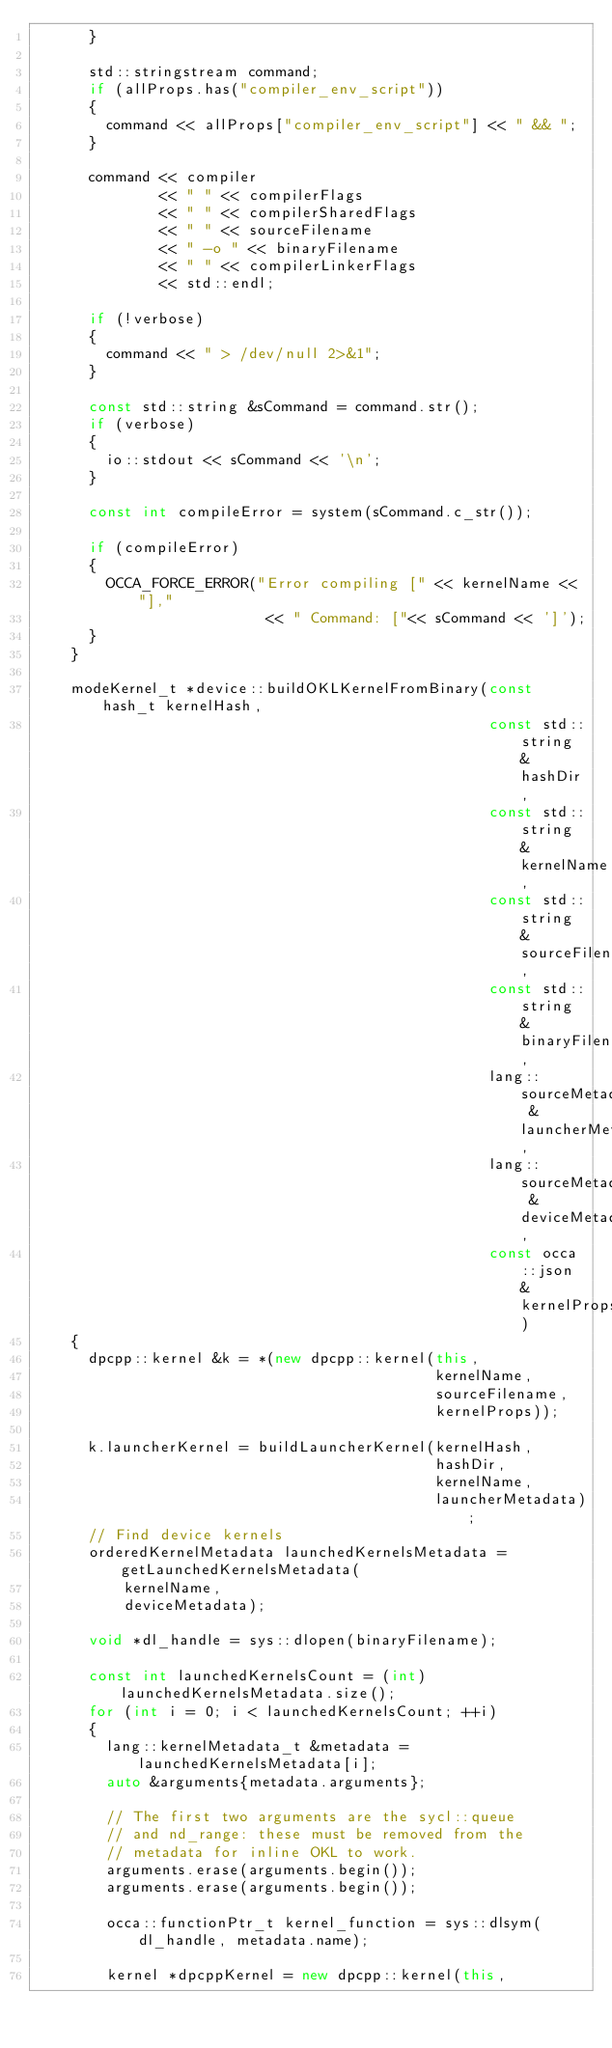<code> <loc_0><loc_0><loc_500><loc_500><_C++_>      }

      std::stringstream command;
      if (allProps.has("compiler_env_script"))
      {
        command << allProps["compiler_env_script"] << " && ";
      }

      command << compiler
              << " " << compilerFlags
              << " " << compilerSharedFlags
              << " " << sourceFilename
              << " -o " << binaryFilename
              << " " << compilerLinkerFlags
              << std::endl;

      if (!verbose)
      {
        command << " > /dev/null 2>&1";
      }

      const std::string &sCommand = command.str();
      if (verbose)
      {
        io::stdout << sCommand << '\n';
      }

      const int compileError = system(sCommand.c_str());

      if (compileError)
      {
        OCCA_FORCE_ERROR("Error compiling [" << kernelName << "],"
                          << " Command: ["<< sCommand << ']');
      }
    }

    modeKernel_t *device::buildOKLKernelFromBinary(const hash_t kernelHash,
                                                   const std::string &hashDir,
                                                   const std::string &kernelName,
                                                   const std::string &sourceFilename,
                                                   const std::string &binaryFilename,
                                                   lang::sourceMetadata_t &launcherMetadata,
                                                   lang::sourceMetadata_t &deviceMetadata,
                                                   const occa::json &kernelProps)
    {
      dpcpp::kernel &k = *(new dpcpp::kernel(this,
                                             kernelName,
                                             sourceFilename,
                                             kernelProps));

      k.launcherKernel = buildLauncherKernel(kernelHash,
                                             hashDir,
                                             kernelName,
                                             launcherMetadata);
      // Find device kernels
      orderedKernelMetadata launchedKernelsMetadata = getLaunchedKernelsMetadata(
          kernelName,
          deviceMetadata);

      void *dl_handle = sys::dlopen(binaryFilename);

      const int launchedKernelsCount = (int)launchedKernelsMetadata.size();
      for (int i = 0; i < launchedKernelsCount; ++i)
      {
        lang::kernelMetadata_t &metadata = launchedKernelsMetadata[i];
        auto &arguments{metadata.arguments};

        // The first two arguments are the sycl::queue
        // and nd_range: these must be removed from the
        // metadata for inline OKL to work.
        arguments.erase(arguments.begin());
        arguments.erase(arguments.begin());

        occa::functionPtr_t kernel_function = sys::dlsym(dl_handle, metadata.name);
       
        kernel *dpcppKernel = new dpcpp::kernel(this,</code> 